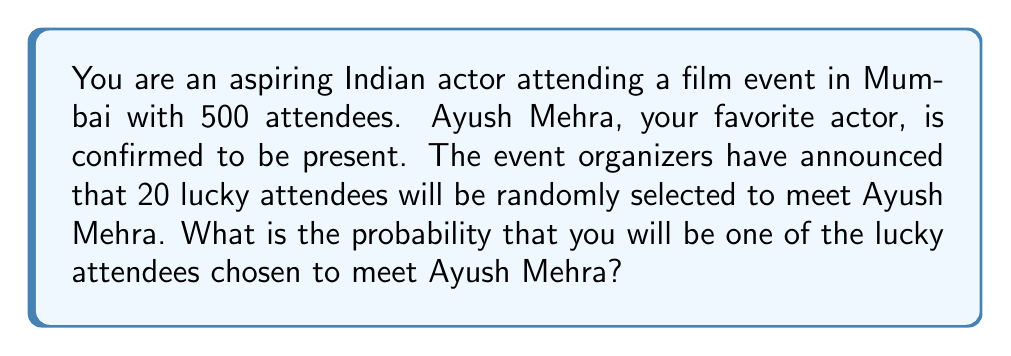Give your solution to this math problem. To solve this problem, we need to use the concept of probability for selecting a specific number of items from a larger set without replacement. In this case, we're selecting 20 people from a total of 500 attendees.

The probability of being selected can be calculated using the following steps:

1. Calculate the number of ways to select 20 people from 500 attendees:
   This is given by the combination formula $\binom{500}{20}$

2. Calculate the number of ways to select 20 people that include you:
   This is equivalent to selecting 19 people from the remaining 499 attendees: $\binom{499}{19}$

3. The probability is then the ratio of favorable outcomes to total outcomes:

   $P(\text{being selected}) = \frac{\binom{499}{19}}{\binom{500}{20}}$

We can simplify this using the combination formula:

$$\binom{n}{k} = \frac{n!}{k!(n-k)!}$$

Substituting the values:

$$P(\text{being selected}) = \frac{\frac{499!}{19!(499-19)!}}{\frac{500!}{20!(500-20)!}}$$

$$= \frac{499! \cdot 20! \cdot 480!}{19! \cdot 480! \cdot 500!}$$

The $480!$ cancels out in the numerator and denominator:

$$= \frac{499 \cdot 20}{500}$$

$$= \frac{9980}{500} = 19.96$$

Therefore, the probability of being selected is $\frac{19.96}{100} = 0.1996$ or $19.96\%$.
Answer: The probability of being selected to meet Ayush Mehra is $0.1996$ or $19.96\%$. 